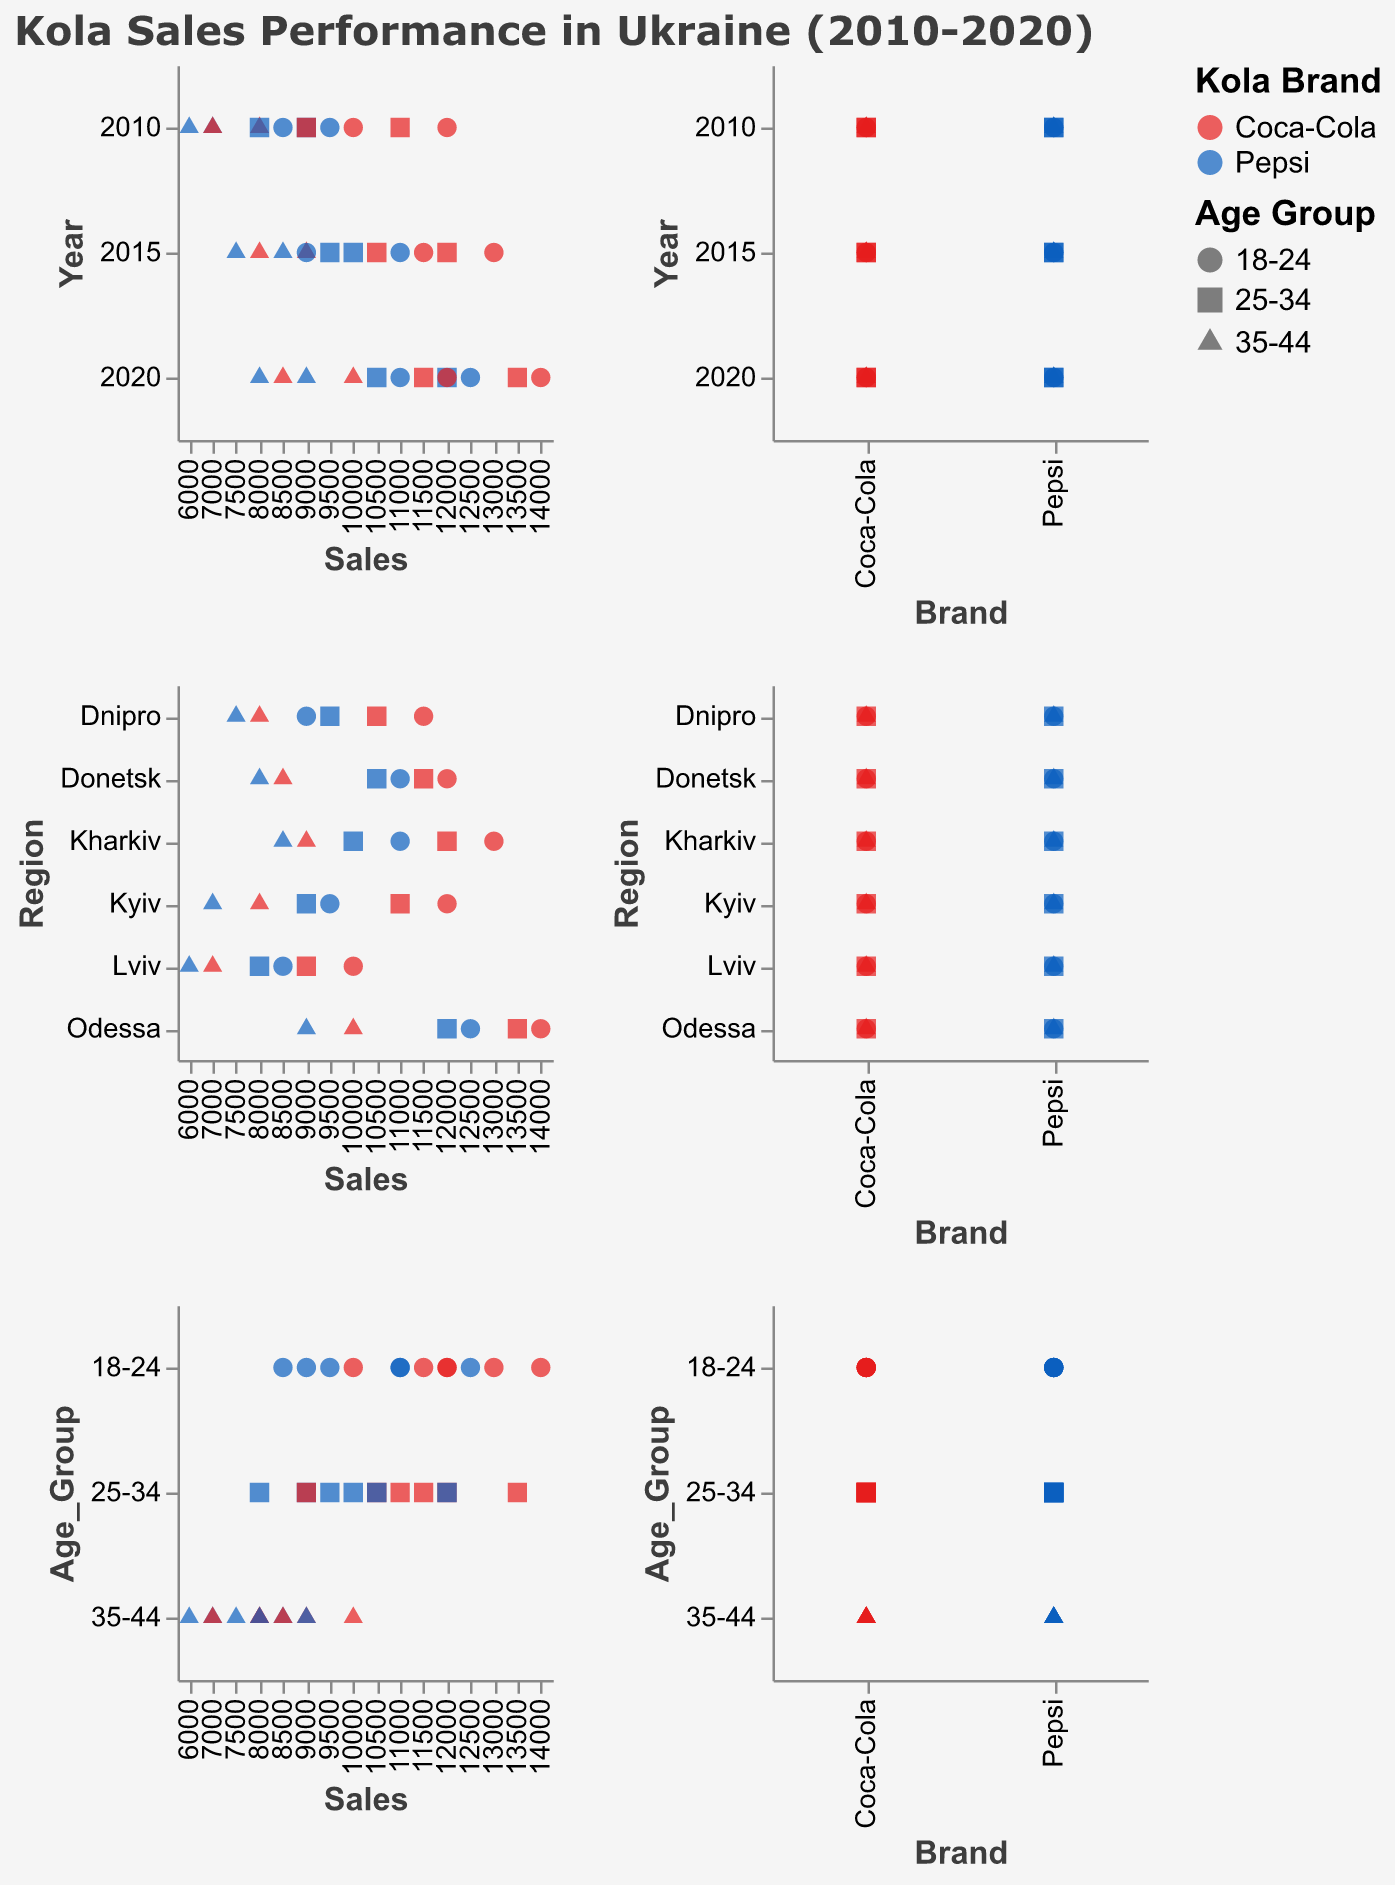How many regions are included in the sales performance data? The scatter plot matrix shows the sales performance data for Kyiv, Lviv, Kharkiv, Dnipro, Odessa, and Donetsk across various years.
Answer: 6 Which age group has the highest sales for Coca-Cola in Kharkiv in 2015? To determine this, locate the Kharkiv region, the year 2015, and filter for Coca-Cola. Compare sales across the 18-24, 25-34, and 35-44 age groups. The 18-24 age group in Kharkiv in 2015 has the highest sales.
Answer: 18-24 What is the average sales of Pepsi across all regions and age groups in 2020? Add the sales for Pepsi across all regions (Odessa and Donetsk) and age groups (18-24, 25-34, 35-44) for the year 2020. Divide the total by the number of data points (6). The sum is 12500 + 12000 + 9000 + 11000 + 10500 + 8000 = 63000. Divide by 6 to get the average.
Answer: 10500 Compare the sales of Coca-Cola in Kyiv in 2010 for the 18-24 age group with the sales of Pepsi in Lviv in 2010 for the 35-44 age group. Which one is higher? The sales of Coca-Cola for the 18-24 age group in Kyiv in 2010 is 12000. The sales of Pepsi for the 35-44 age group in Lviv in 2010 is 6000. Comparing 12000 and 6000, Coca-Cola in Kyiv is higher.
Answer: Coca-Cola in Kyiv For which region and year combination do we see the highest Pepsi sales for the age group 25-34? Look through all regions and years for the 25-34 age group and identify the highest sales for Pepsi. Pepsi sales for 25-34 age group in Odessa in 2020 is 12000, which is the highest.
Answer: Odessa in 2020 What is the difference in sales between Coca-Cola and Pepsi in Dnipro in 2015 for the 18-24 age group? Coca-Cola sales in Dnipro in 2015 for the 18-24 age group is 11500. Pepsi sales in the same category is 9000. The difference is 11500 - 9000 = 2500.
Answer: 2500 Which brand has the least sales in Lviv in 2010 for the 35-44 age group? Compare the sales for Coca-Cola and Pepsi in Lviv for the 35-44 age group in 2010. Pepsi has 6000 sales, which is less than Coca-Cola's 7000 sales.
Answer: Pepsi Identify the trend in Coca-Cola sales for the 25-34 age group across all regions from 2010 to 2020. Examine the sales of Coca-Cola for the 25-34 age group in Kyiv, Lviv, Kharkiv, Dnipro, Odessa, and Donetsk from 2010 to 2020. The data indicates increasing sales over time: 11000 (2010), 9000 (2010), 12000 (2015), 10500 (2015), 13500 (2020), 11500 (2020).
Answer: Increasing In which year and region did Pepsi sales exceed Coca-Cola sales for the 35-44 age group? Compare the sales for Pepsi and Coca-Cola in all regions and years for the 35-44 age group. In none of the combinations does Pepsi's sales exceed Coca-Cola's sales in the 35-44 age group.
Answer: None 